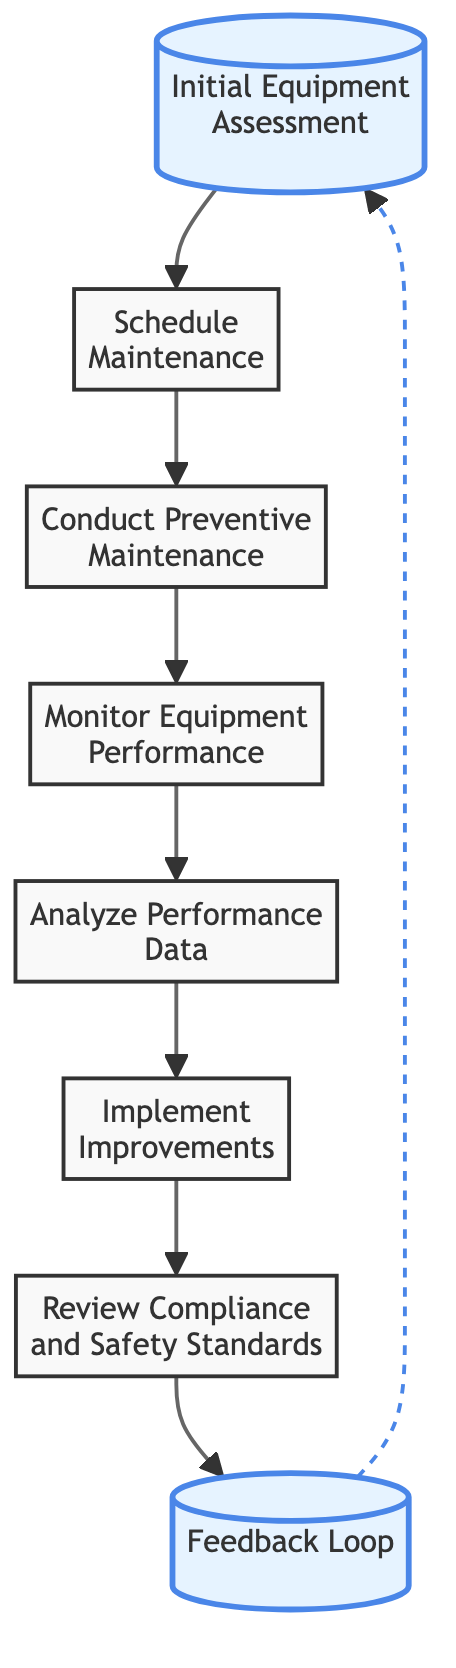What is the first step in the equipment maintenance workflow? The diagram starts with the node labeled "Initial Equipment Assessment," which is the first step in the workflow.
Answer: Initial Equipment Assessment How many nodes are present in the workflow? By counting each distinct step represented in the diagram, we find there are a total of eight nodes.
Answer: 8 Which node comes after "Monitor Equipment Performance"? According to the flow of the diagram, "Analyze Performance Data" directly follows "Monitor Equipment Performance."
Answer: Analyze Performance Data What type of lines connect the nodes? The primary connections between the nodes are represented by solid directed arrows, indicating the flow of the process.
Answer: Solid arrows What action is taken after "Conduct Preventive Maintenance"? The next step following "Conduct Preventive Maintenance" is "Monitor Equipment Performance," as indicated by the arrow in the diagram.
Answer: Monitor Equipment Performance Which step includes ensuring compliance with safety standards? The node that involves ensuring compliance with safety regulations and standards is titled "Review Compliance and Safety Standards."
Answer: Review Compliance and Safety Standards What is the final step in the workflow before collecting feedback? The last step before the feedback is collected is "Review Compliance and Safety Standards," which leads to the feedback loop.
Answer: Review Compliance and Safety Standards How does feedback influence the workflow according to the diagram? Feedback collected from maintenance personnel creates a loop that leads back to the "Initial Equipment Assessment," suggesting continuous improvement in the workflow.
Answer: Continuous improvement What is indicated by the dashed line in the diagram? The dashed line represents a feedback loop connecting the end of the workflow back to the beginning step, emphasizing the iterative nature of the maintenance process.
Answer: Feedback loop 